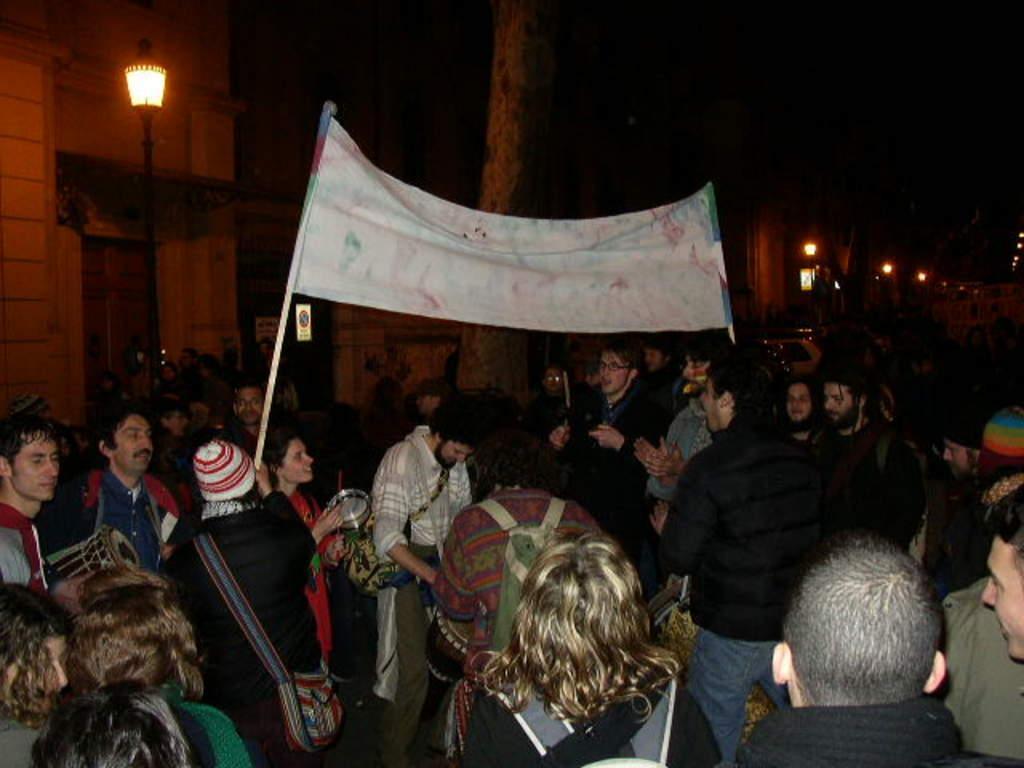In one or two sentences, can you explain what this image depicts? In this image there are group of people standing and some of them are wearing bags, and two of them are holding board. And in the background there are buildings, poles, lights and plants and tree. 